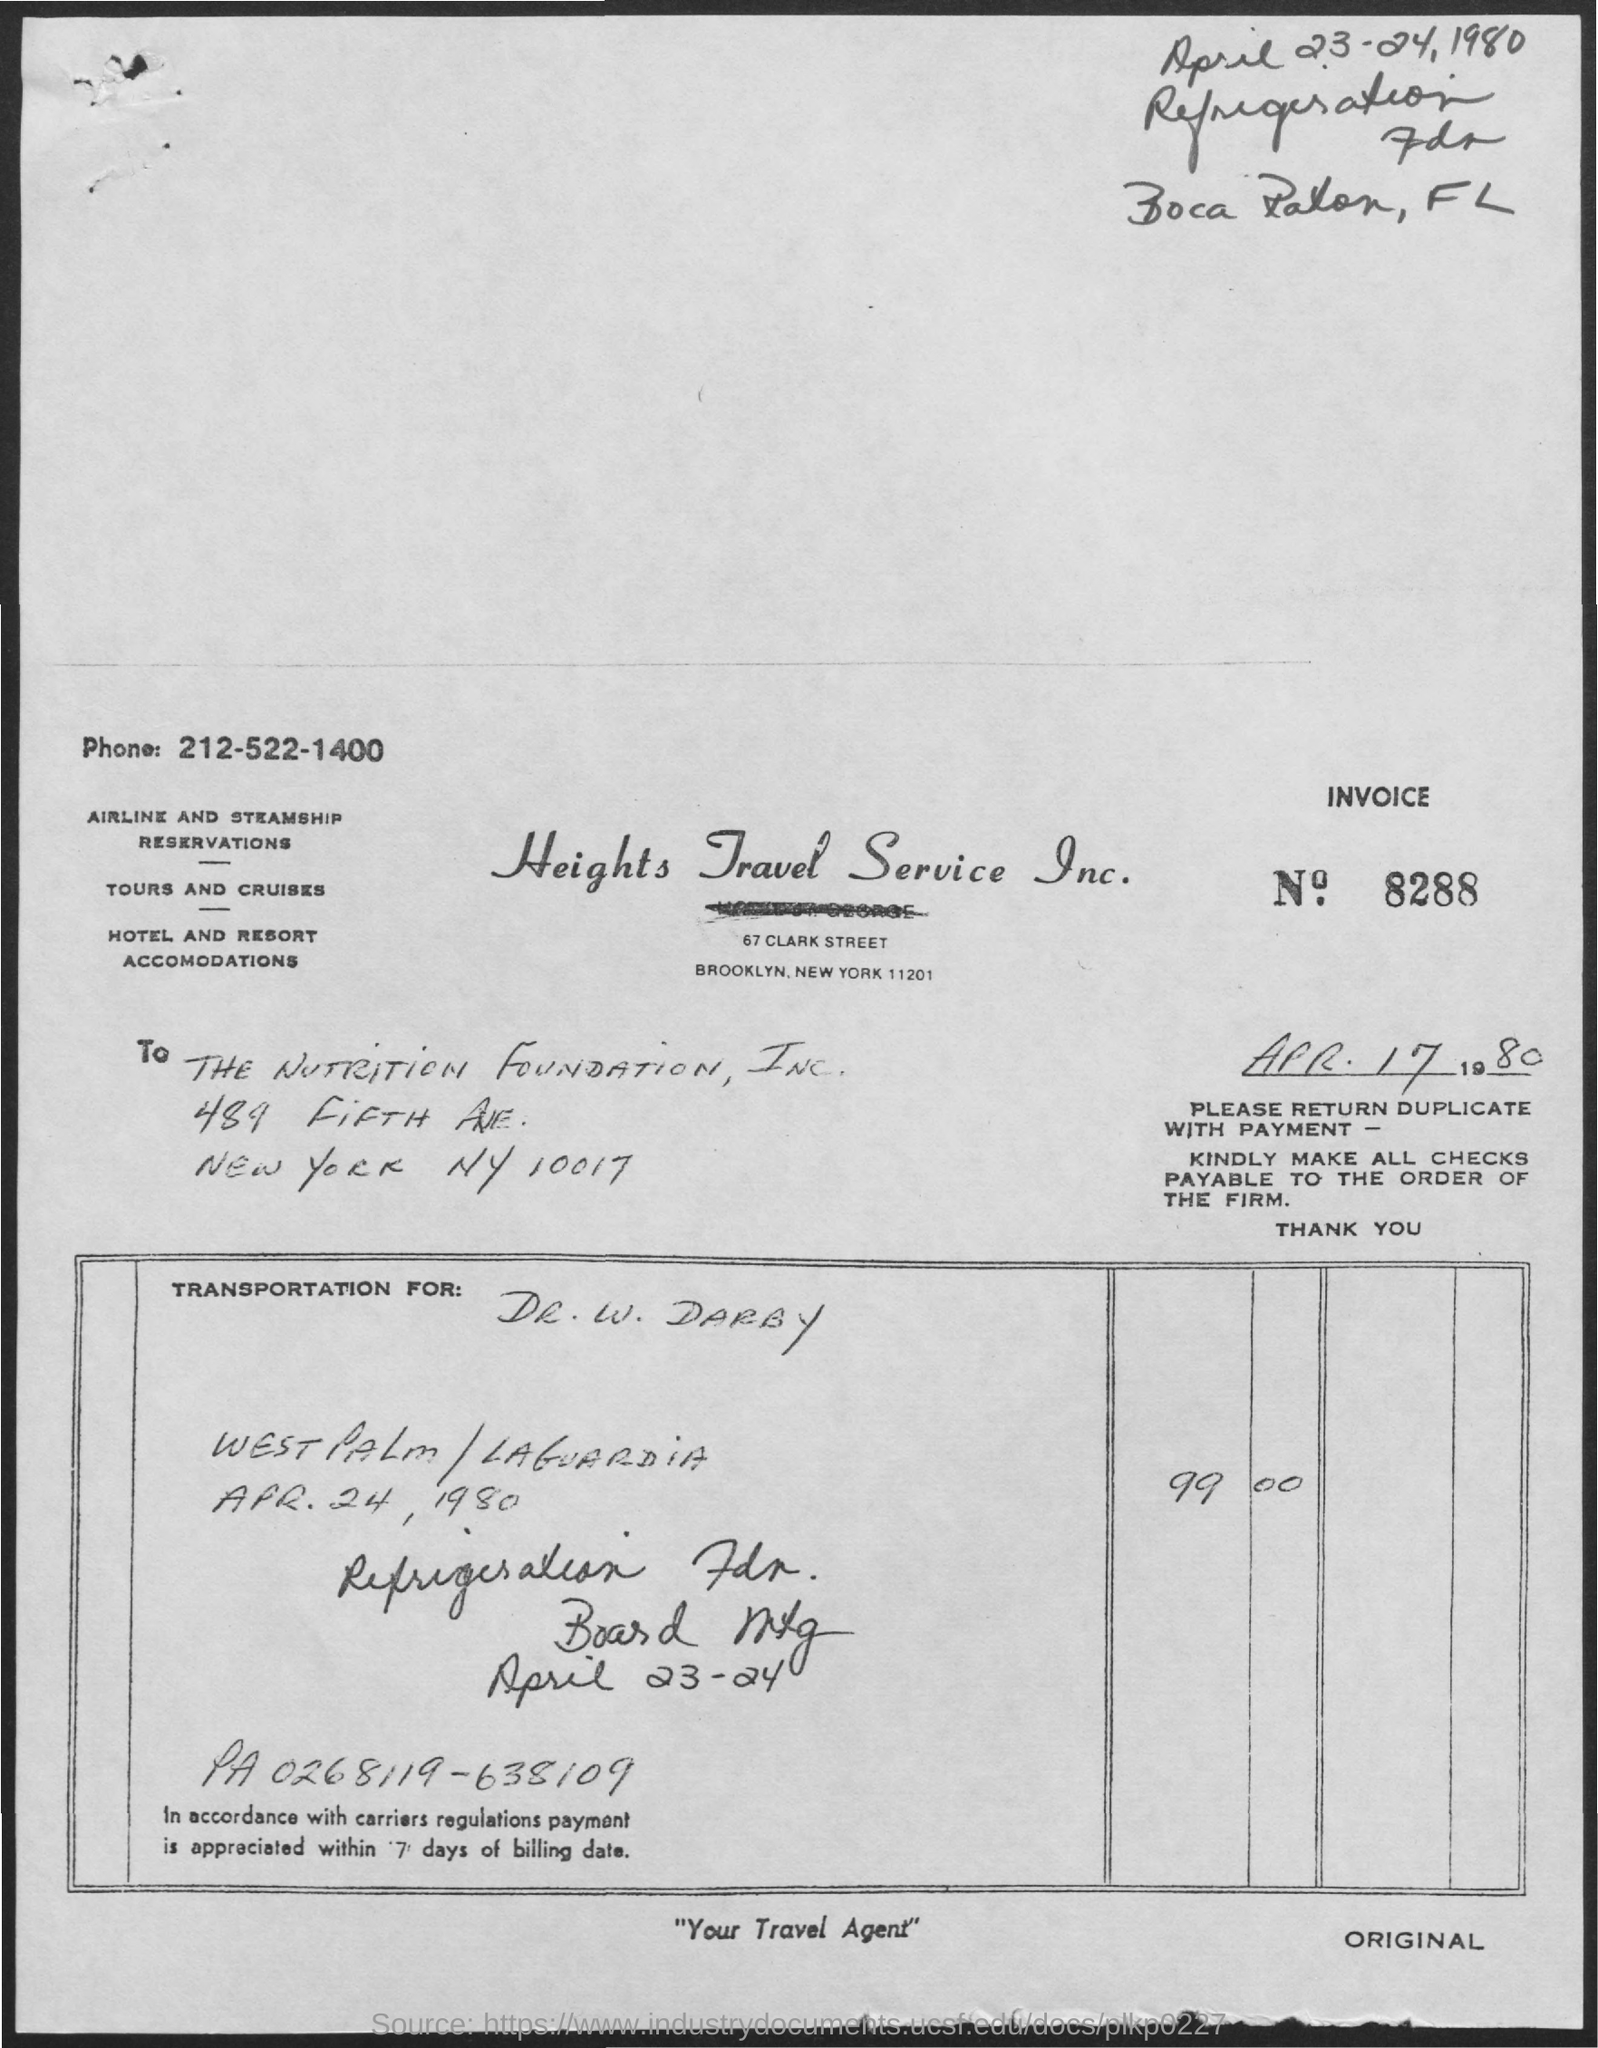Specify some key components in this picture. The document is addressed to the Nutrition Foundation, Inc. The phone number mentioned on the invoice is 212-522-1400. Payment must be made within 7 days of the billing date. 